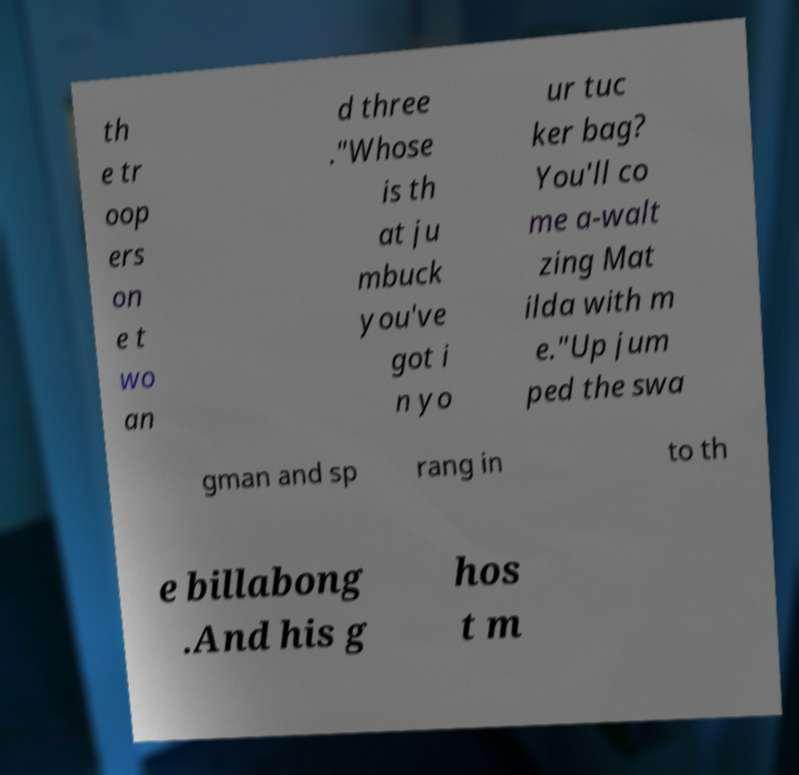Please read and relay the text visible in this image. What does it say? th e tr oop ers on e t wo an d three ."Whose is th at ju mbuck you've got i n yo ur tuc ker bag? You'll co me a-walt zing Mat ilda with m e."Up jum ped the swa gman and sp rang in to th e billabong .And his g hos t m 